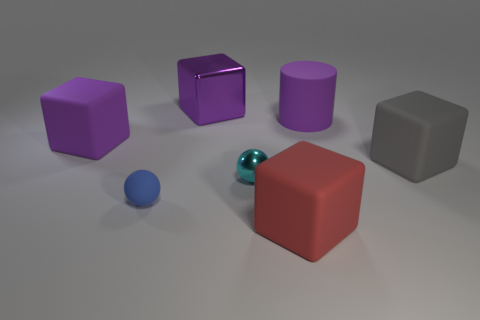What number of large gray blocks are made of the same material as the small cyan sphere?
Your answer should be very brief. 0. How many things are large cubes or large purple objects that are right of the small shiny ball?
Make the answer very short. 5. Are the large purple object that is right of the large red rubber object and the red cube made of the same material?
Make the answer very short. Yes. There is a metallic object that is the same size as the red block; what color is it?
Offer a terse response. Purple. Is there a large red matte object of the same shape as the large metallic object?
Your response must be concise. Yes. The small thing in front of the shiny thing in front of the purple matte object that is left of the large red block is what color?
Keep it short and to the point. Blue. How many rubber things are green things or blocks?
Provide a short and direct response. 3. Is the number of tiny blue rubber objects in front of the metal block greater than the number of large gray things that are on the left side of the purple rubber cylinder?
Ensure brevity in your answer.  Yes. What number of other objects are the same size as the gray thing?
Your response must be concise. 4. How big is the object on the right side of the purple thing that is on the right side of the small cyan shiny sphere?
Keep it short and to the point. Large. 